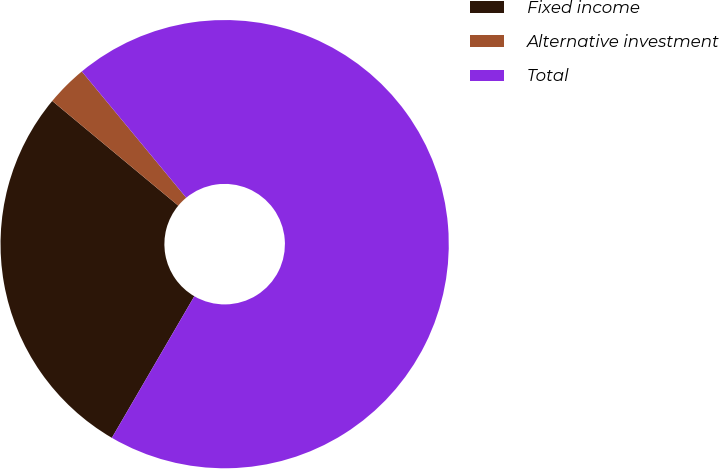Convert chart. <chart><loc_0><loc_0><loc_500><loc_500><pie_chart><fcel>Fixed income<fcel>Alternative investment<fcel>Total<nl><fcel>27.64%<fcel>2.97%<fcel>69.39%<nl></chart> 